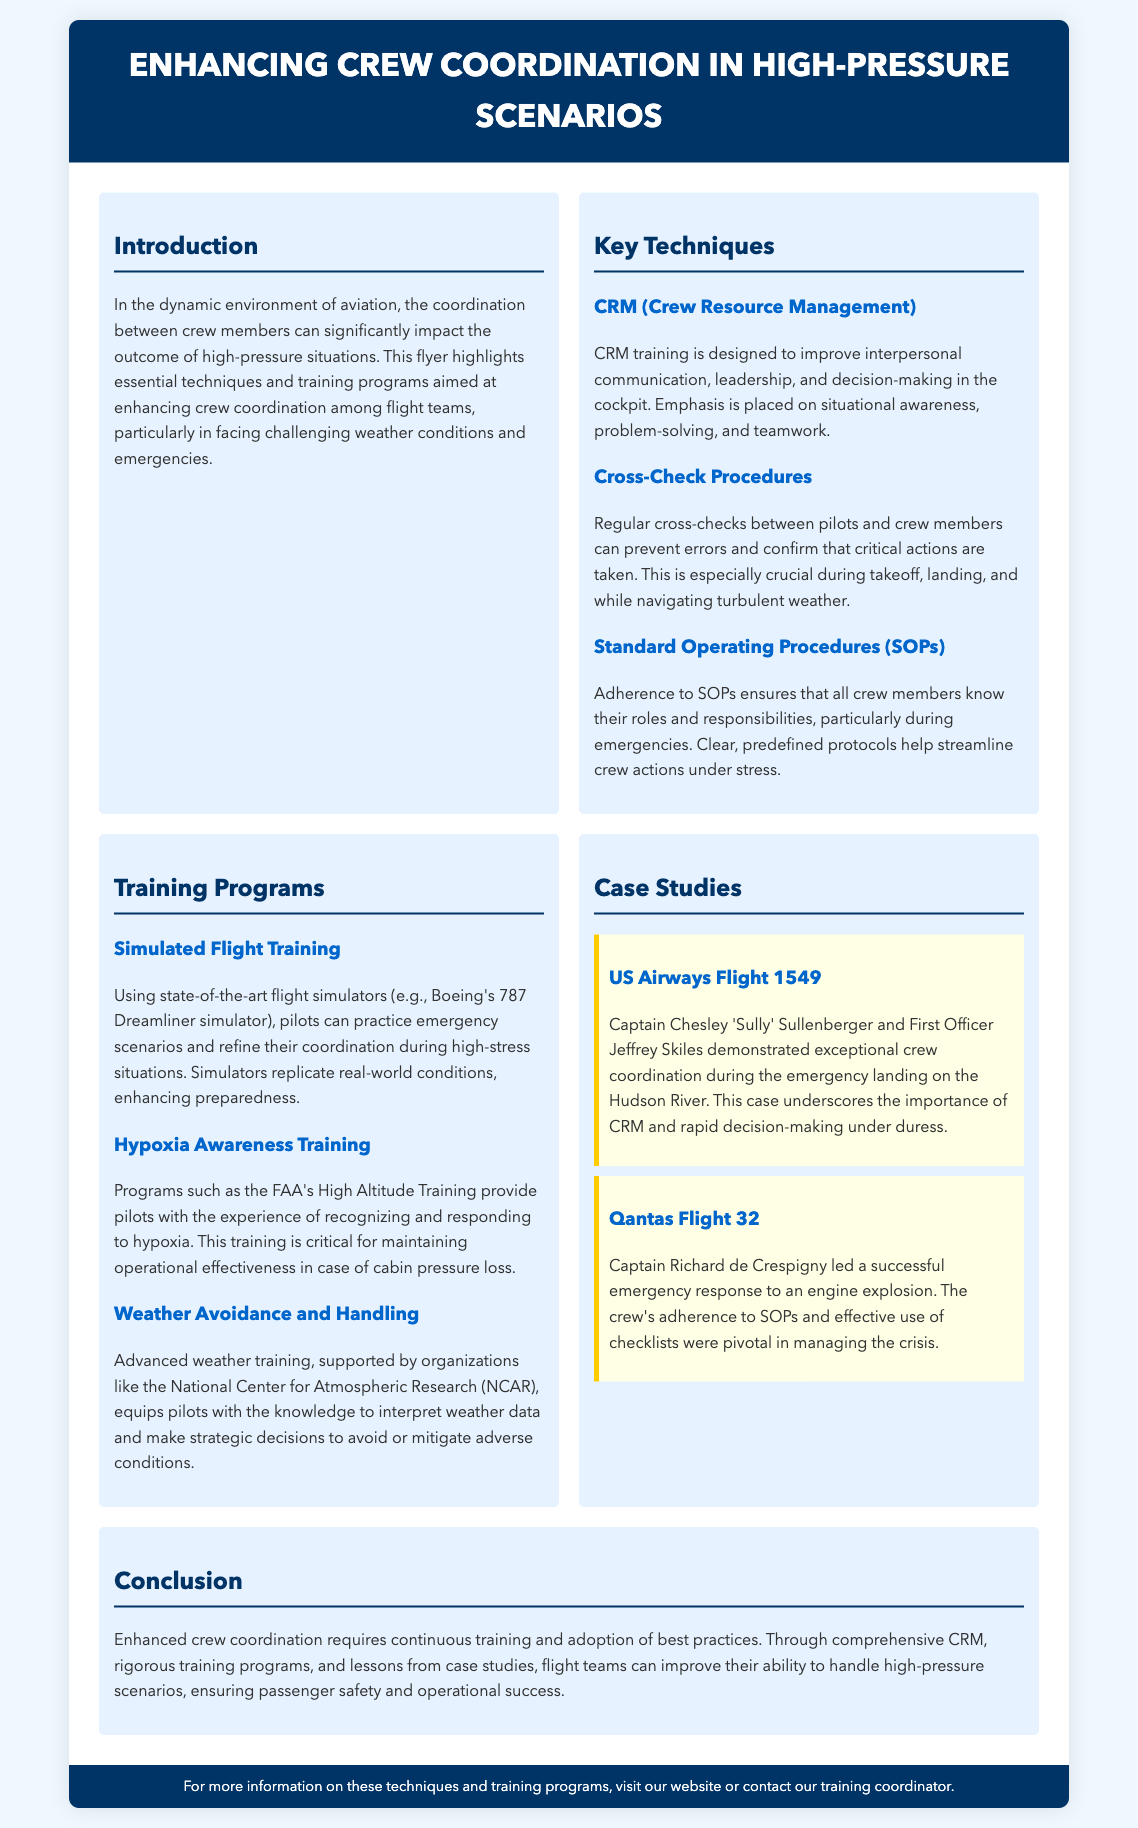What is the main focus of the flyer? The flyer highlights essential techniques and training programs aimed at enhancing crew coordination among flight teams, particularly in facing challenging weather conditions and emergencies.
Answer: Enhancing crew coordination What does CRM stand for? CRM stands for Crew Resource Management, which is designed to improve interpersonal communication, leadership, and decision-making in the cockpit.
Answer: Crew Resource Management Which flight simulator is mentioned? The flyer mentions the Boeing's 787 Dreamliner simulator, used for practicing emergency scenarios.
Answer: Boeing's 787 Dreamliner simulator What case study features Captain Sully Sullenberger? The case study featuring Captain Sully Sullenberger is about US Airways Flight 1549, highlighting exceptional crew coordination during the emergency landing.
Answer: US Airways Flight 1549 What type of training does the FAA provide related to high altitude? The FAA's High Altitude Training provides pilots experience in recognizing and responding to hypoxia.
Answer: High Altitude Training What is emphasized during cross-check procedures? Regular cross-checks between pilots and crew members prevent errors and confirm that critical actions are taken.
Answer: Prevent errors How important is adherence to SOPs during emergencies? Adherence to SOPs ensures that all crew members know their roles and responsibilities, particularly during emergencies.
Answer: Very important What organization supports advanced weather training? The National Center for Atmospheric Research (NCAR) supports advanced weather training for pilots.
Answer: National Center for Atmospheric Research What is the primary benefit of simulated flight training? Simulated flight training enhances preparedness by replicating real-world conditions and practicing emergency scenarios.
Answer: Enhances preparedness 